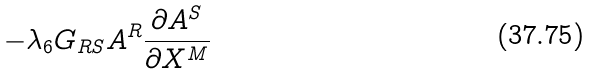Convert formula to latex. <formula><loc_0><loc_0><loc_500><loc_500>- \lambda _ { 6 } G _ { R S } A ^ { R } \frac { \partial A ^ { S } } { \partial X ^ { M } }</formula> 